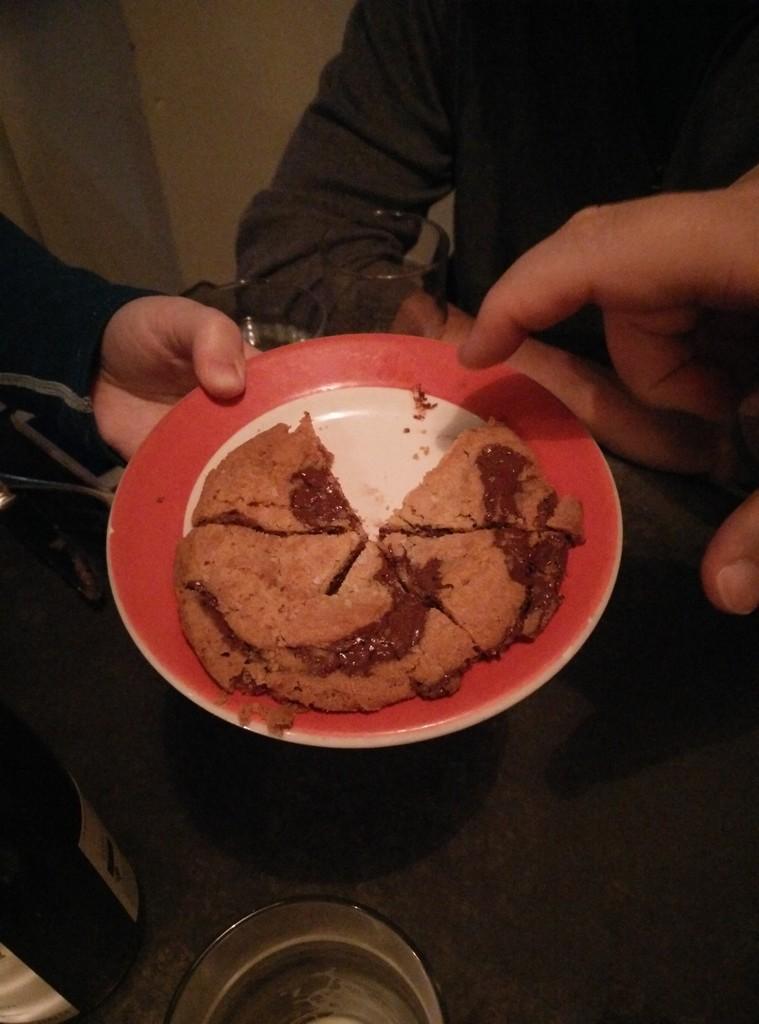Please provide a concise description of this image. In this image we can see food item in a plate and a person's hand on the left side is holding the plate and on the right side we can see a person and persons hand. we can see a bottle, knife and a bowl on a table. In the background we can see the wall. 